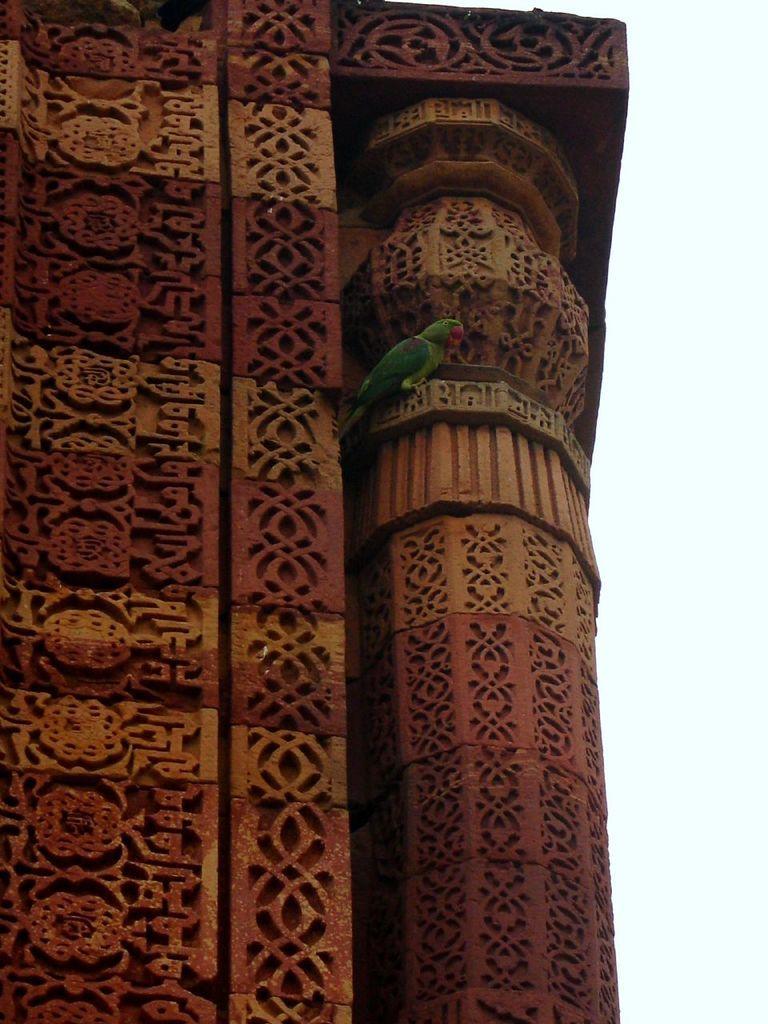Describe this image in one or two sentences. Here in this picture we can see a monumental structure present over a place and we can also see a parrot present on it. 